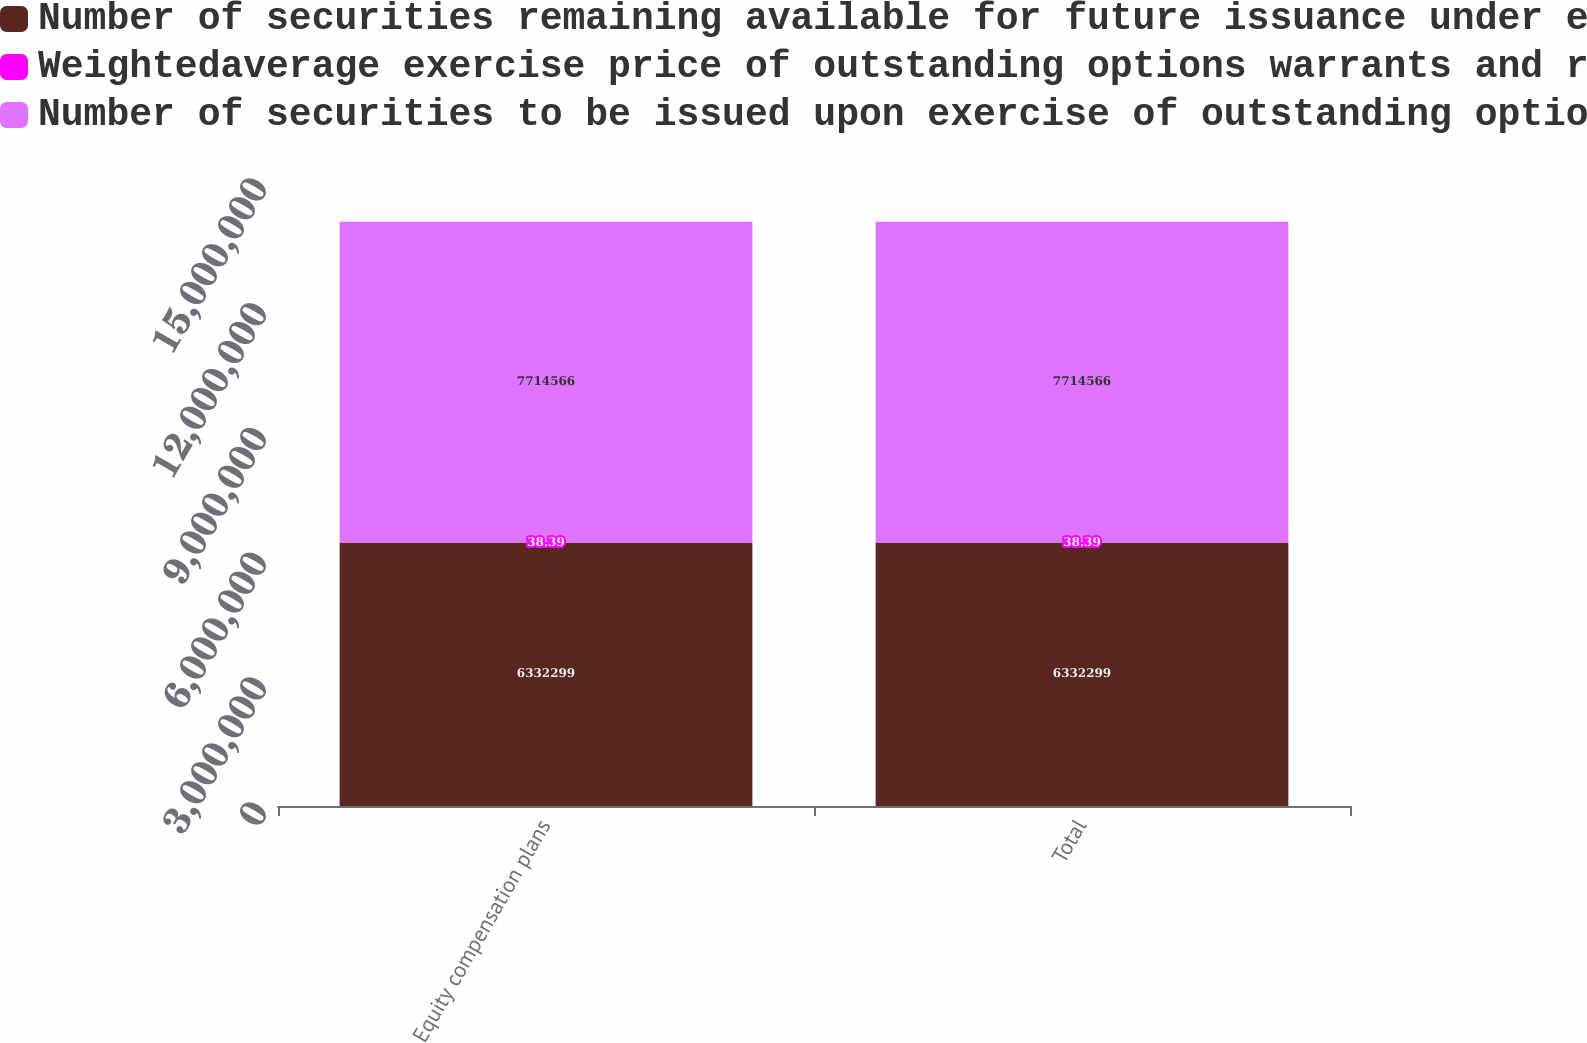Convert chart to OTSL. <chart><loc_0><loc_0><loc_500><loc_500><stacked_bar_chart><ecel><fcel>Equity compensation plans<fcel>Total<nl><fcel>Number of securities remaining available for future issuance under equity compensation plan excluding securities reflected in column a at December 31 2013 c<fcel>6.3323e+06<fcel>6.3323e+06<nl><fcel>Weightedaverage exercise price of outstanding options warrants and rights b<fcel>38.39<fcel>38.39<nl><fcel>Number of securities to be issued upon exercise of outstanding options warrants and rights at December 31 2013 a<fcel>7.71457e+06<fcel>7.71457e+06<nl></chart> 